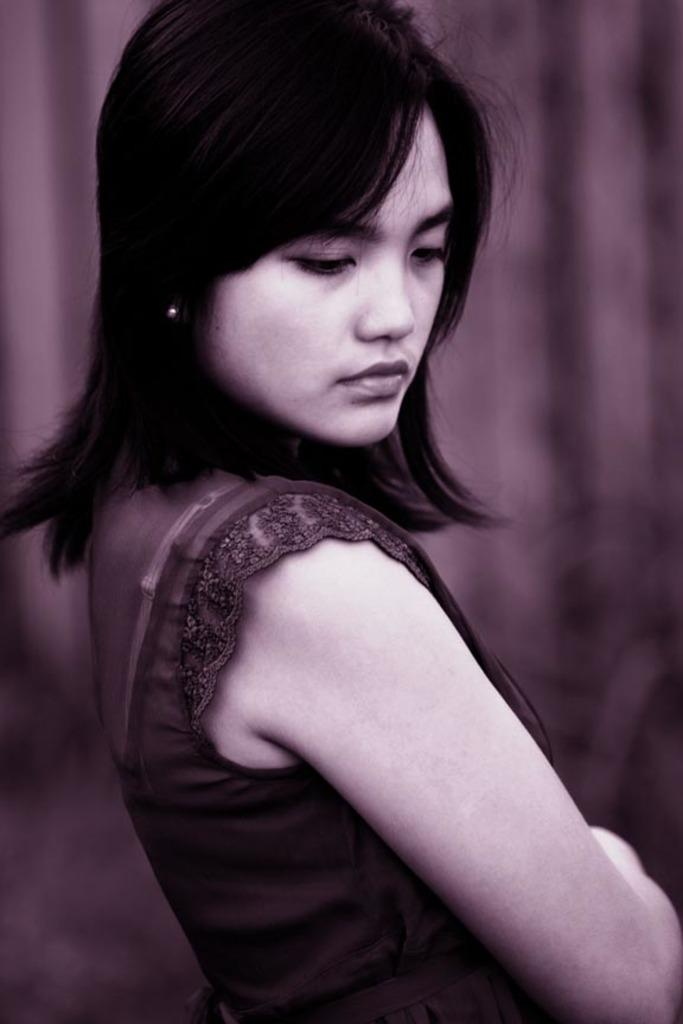What is the main subject of the image? The main subject of the image is a woman. What is the woman wearing in the image? The woman is wearing a black dress. Can you describe the background of the image? The background of the image is blurred. What type of comb is the woman using in the image? There is no comb present in the image. Is the woman driving a vehicle in the image? There is no vehicle or indication of driving in the image. 